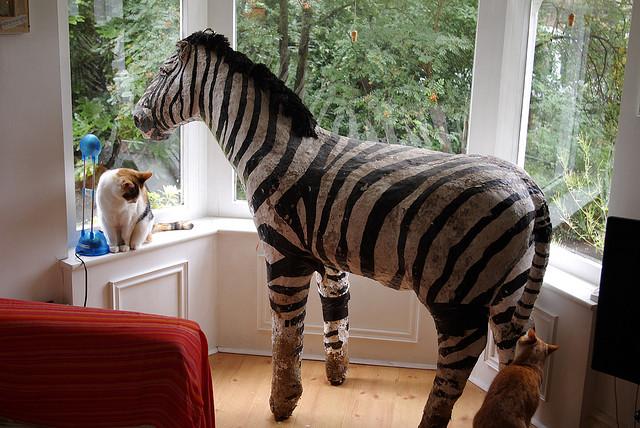What's the color of the couch?
Short answer required. Red. Are the animals in the picture real?
Concise answer only. Yes. How many cats are here?
Answer briefly. 2. 